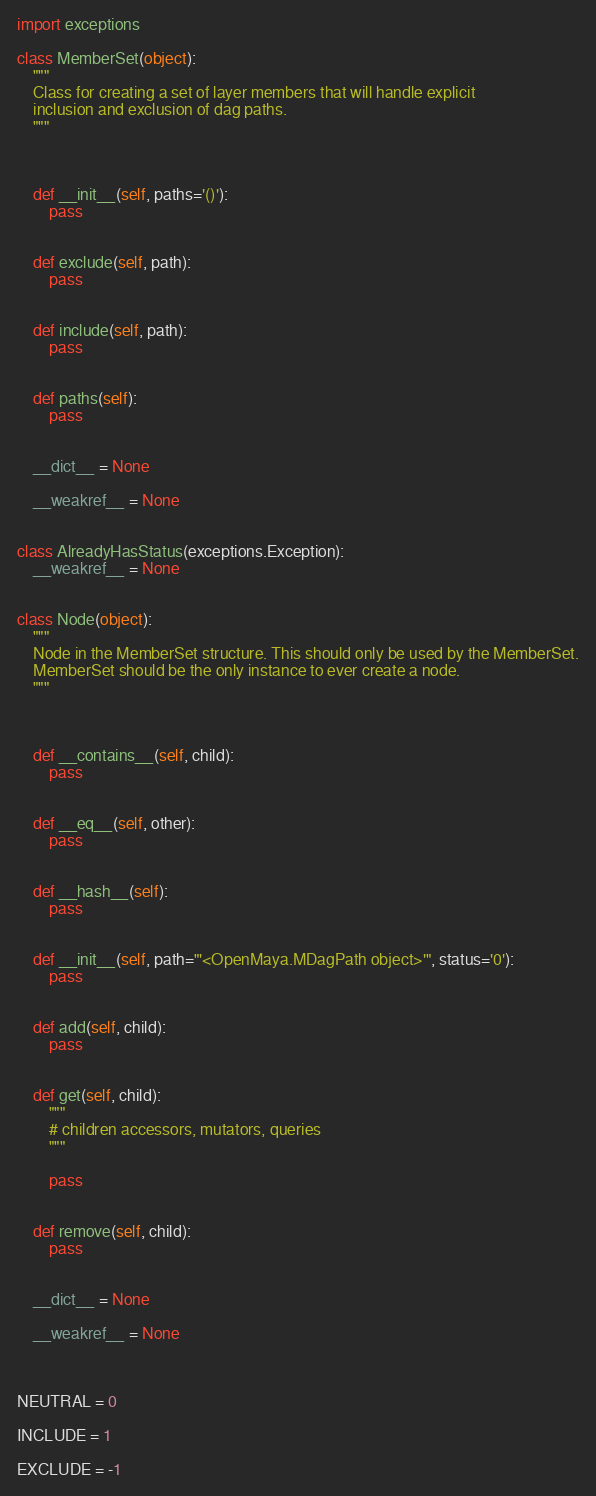Convert code to text. <code><loc_0><loc_0><loc_500><loc_500><_Python_>import exceptions

class MemberSet(object):
    """
    Class for creating a set of layer members that will handle explicit 
    inclusion and exclusion of dag paths.
    """
    
    
    
    def __init__(self, paths='()'):
        pass
    
    
    def exclude(self, path):
        pass
    
    
    def include(self, path):
        pass
    
    
    def paths(self):
        pass
    
    
    __dict__ = None
    
    __weakref__ = None


class AlreadyHasStatus(exceptions.Exception):
    __weakref__ = None


class Node(object):
    """
    Node in the MemberSet structure. This should only be used by the MemberSet.
    MemberSet should be the only instance to ever create a node.
    """
    
    
    
    def __contains__(self, child):
        pass
    
    
    def __eq__(self, other):
        pass
    
    
    def __hash__(self):
        pass
    
    
    def __init__(self, path="'<OpenMaya.MDagPath object>'", status='0'):
        pass
    
    
    def add(self, child):
        pass
    
    
    def get(self, child):
        """
        # children accessors, mutators, queries
        """
    
        pass
    
    
    def remove(self, child):
        pass
    
    
    __dict__ = None
    
    __weakref__ = None



NEUTRAL = 0

INCLUDE = 1

EXCLUDE = -1


</code> 